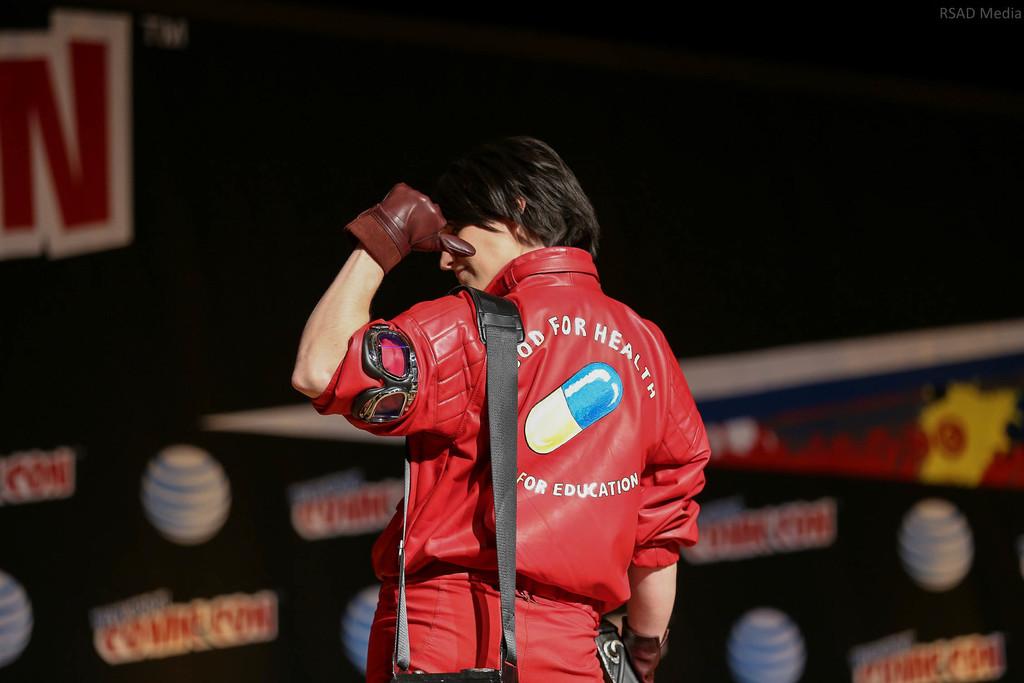What is the giant letter to the top left?
Your answer should be compact. N. 